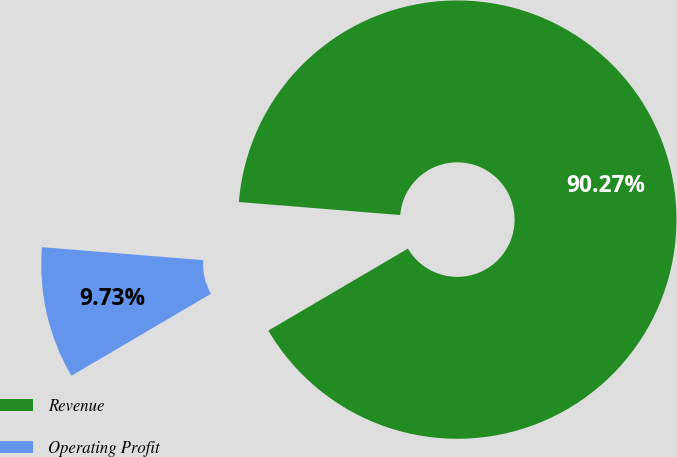<chart> <loc_0><loc_0><loc_500><loc_500><pie_chart><fcel>Revenue<fcel>Operating Profit<nl><fcel>90.27%<fcel>9.73%<nl></chart> 